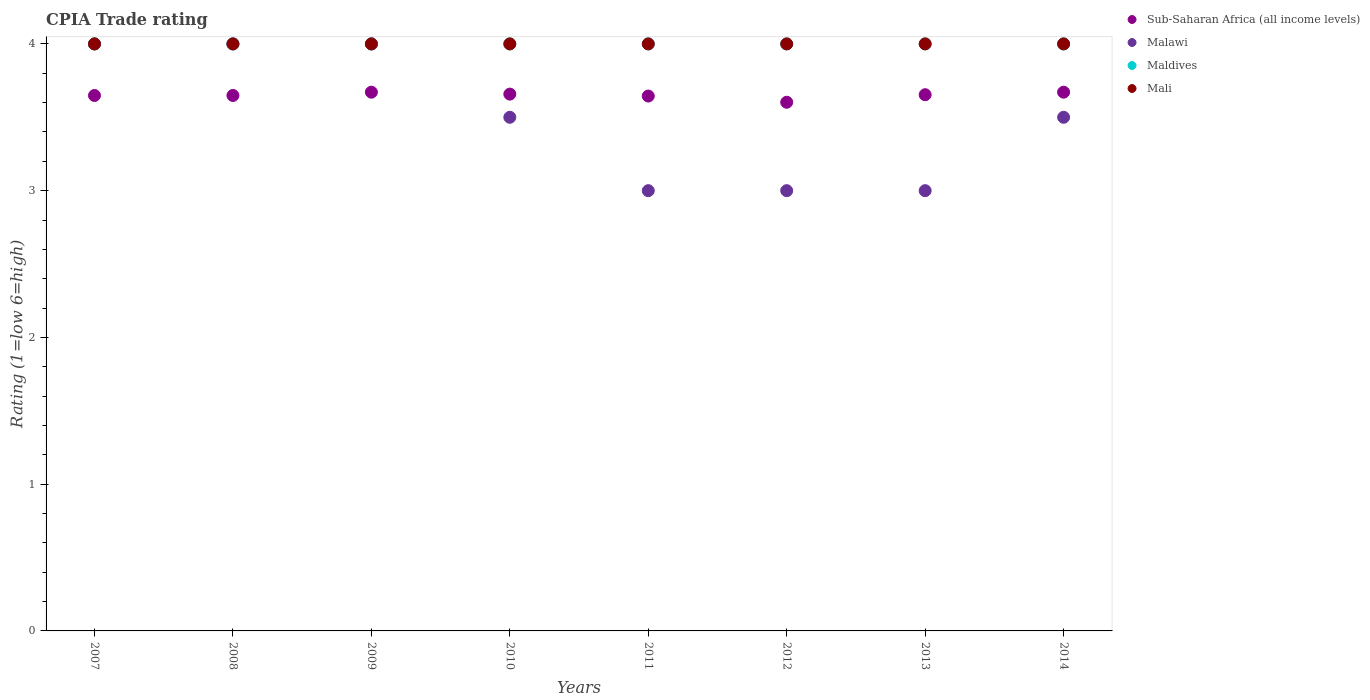What is the CPIA rating in Mali in 2013?
Provide a short and direct response. 4. Across all years, what is the maximum CPIA rating in Sub-Saharan Africa (all income levels)?
Provide a short and direct response. 3.67. Across all years, what is the minimum CPIA rating in Sub-Saharan Africa (all income levels)?
Provide a succinct answer. 3.6. In which year was the CPIA rating in Maldives maximum?
Your response must be concise. 2007. What is the total CPIA rating in Maldives in the graph?
Ensure brevity in your answer.  32. What is the difference between the CPIA rating in Sub-Saharan Africa (all income levels) in 2010 and that in 2011?
Ensure brevity in your answer.  0.01. What is the difference between the CPIA rating in Mali in 2007 and the CPIA rating in Maldives in 2012?
Provide a short and direct response. 0. What is the average CPIA rating in Sub-Saharan Africa (all income levels) per year?
Keep it short and to the point. 3.65. What is the ratio of the CPIA rating in Malawi in 2007 to that in 2012?
Provide a succinct answer. 1.33. Is the CPIA rating in Maldives in 2010 less than that in 2014?
Keep it short and to the point. No. What is the difference between the highest and the second highest CPIA rating in Malawi?
Offer a terse response. 0. What is the difference between the highest and the lowest CPIA rating in Sub-Saharan Africa (all income levels)?
Give a very brief answer. 0.07. Is it the case that in every year, the sum of the CPIA rating in Sub-Saharan Africa (all income levels) and CPIA rating in Mali  is greater than the sum of CPIA rating in Malawi and CPIA rating in Maldives?
Your response must be concise. No. Is it the case that in every year, the sum of the CPIA rating in Sub-Saharan Africa (all income levels) and CPIA rating in Mali  is greater than the CPIA rating in Malawi?
Ensure brevity in your answer.  Yes. How many dotlines are there?
Ensure brevity in your answer.  4. Are the values on the major ticks of Y-axis written in scientific E-notation?
Make the answer very short. No. Where does the legend appear in the graph?
Provide a short and direct response. Top right. How are the legend labels stacked?
Provide a succinct answer. Vertical. What is the title of the graph?
Give a very brief answer. CPIA Trade rating. What is the label or title of the Y-axis?
Offer a terse response. Rating (1=low 6=high). What is the Rating (1=low 6=high) in Sub-Saharan Africa (all income levels) in 2007?
Make the answer very short. 3.65. What is the Rating (1=low 6=high) in Maldives in 2007?
Give a very brief answer. 4. What is the Rating (1=low 6=high) in Mali in 2007?
Keep it short and to the point. 4. What is the Rating (1=low 6=high) of Sub-Saharan Africa (all income levels) in 2008?
Your answer should be compact. 3.65. What is the Rating (1=low 6=high) in Mali in 2008?
Your answer should be compact. 4. What is the Rating (1=low 6=high) of Sub-Saharan Africa (all income levels) in 2009?
Ensure brevity in your answer.  3.67. What is the Rating (1=low 6=high) of Malawi in 2009?
Your answer should be very brief. 4. What is the Rating (1=low 6=high) in Mali in 2009?
Your answer should be very brief. 4. What is the Rating (1=low 6=high) in Sub-Saharan Africa (all income levels) in 2010?
Your answer should be compact. 3.66. What is the Rating (1=low 6=high) in Malawi in 2010?
Provide a short and direct response. 3.5. What is the Rating (1=low 6=high) of Sub-Saharan Africa (all income levels) in 2011?
Make the answer very short. 3.64. What is the Rating (1=low 6=high) of Maldives in 2011?
Your answer should be compact. 4. What is the Rating (1=low 6=high) in Mali in 2011?
Your answer should be very brief. 4. What is the Rating (1=low 6=high) of Sub-Saharan Africa (all income levels) in 2012?
Offer a terse response. 3.6. What is the Rating (1=low 6=high) in Malawi in 2012?
Offer a very short reply. 3. What is the Rating (1=low 6=high) of Maldives in 2012?
Give a very brief answer. 4. What is the Rating (1=low 6=high) in Mali in 2012?
Keep it short and to the point. 4. What is the Rating (1=low 6=high) in Sub-Saharan Africa (all income levels) in 2013?
Provide a short and direct response. 3.65. What is the Rating (1=low 6=high) in Malawi in 2013?
Provide a short and direct response. 3. What is the Rating (1=low 6=high) of Mali in 2013?
Your answer should be very brief. 4. What is the Rating (1=low 6=high) of Sub-Saharan Africa (all income levels) in 2014?
Keep it short and to the point. 3.67. What is the Rating (1=low 6=high) of Maldives in 2014?
Provide a succinct answer. 4. Across all years, what is the maximum Rating (1=low 6=high) in Sub-Saharan Africa (all income levels)?
Your response must be concise. 3.67. Across all years, what is the maximum Rating (1=low 6=high) of Maldives?
Provide a short and direct response. 4. Across all years, what is the maximum Rating (1=low 6=high) of Mali?
Make the answer very short. 4. Across all years, what is the minimum Rating (1=low 6=high) of Sub-Saharan Africa (all income levels)?
Your answer should be compact. 3.6. Across all years, what is the minimum Rating (1=low 6=high) of Maldives?
Offer a very short reply. 4. Across all years, what is the minimum Rating (1=low 6=high) of Mali?
Give a very brief answer. 4. What is the total Rating (1=low 6=high) in Sub-Saharan Africa (all income levels) in the graph?
Ensure brevity in your answer.  29.2. What is the total Rating (1=low 6=high) in Malawi in the graph?
Provide a short and direct response. 28. What is the total Rating (1=low 6=high) of Mali in the graph?
Offer a very short reply. 32. What is the difference between the Rating (1=low 6=high) in Sub-Saharan Africa (all income levels) in 2007 and that in 2008?
Your answer should be compact. 0. What is the difference between the Rating (1=low 6=high) of Maldives in 2007 and that in 2008?
Make the answer very short. 0. What is the difference between the Rating (1=low 6=high) in Mali in 2007 and that in 2008?
Make the answer very short. 0. What is the difference between the Rating (1=low 6=high) in Sub-Saharan Africa (all income levels) in 2007 and that in 2009?
Offer a terse response. -0.02. What is the difference between the Rating (1=low 6=high) in Malawi in 2007 and that in 2009?
Offer a terse response. 0. What is the difference between the Rating (1=low 6=high) in Mali in 2007 and that in 2009?
Offer a very short reply. 0. What is the difference between the Rating (1=low 6=high) of Sub-Saharan Africa (all income levels) in 2007 and that in 2010?
Your response must be concise. -0.01. What is the difference between the Rating (1=low 6=high) in Malawi in 2007 and that in 2010?
Offer a very short reply. 0.5. What is the difference between the Rating (1=low 6=high) in Maldives in 2007 and that in 2010?
Make the answer very short. 0. What is the difference between the Rating (1=low 6=high) of Sub-Saharan Africa (all income levels) in 2007 and that in 2011?
Your answer should be very brief. 0. What is the difference between the Rating (1=low 6=high) of Maldives in 2007 and that in 2011?
Your answer should be very brief. 0. What is the difference between the Rating (1=low 6=high) of Sub-Saharan Africa (all income levels) in 2007 and that in 2012?
Provide a succinct answer. 0.05. What is the difference between the Rating (1=low 6=high) in Mali in 2007 and that in 2012?
Make the answer very short. 0. What is the difference between the Rating (1=low 6=high) in Sub-Saharan Africa (all income levels) in 2007 and that in 2013?
Give a very brief answer. -0.01. What is the difference between the Rating (1=low 6=high) in Malawi in 2007 and that in 2013?
Give a very brief answer. 1. What is the difference between the Rating (1=low 6=high) of Sub-Saharan Africa (all income levels) in 2007 and that in 2014?
Make the answer very short. -0.02. What is the difference between the Rating (1=low 6=high) of Sub-Saharan Africa (all income levels) in 2008 and that in 2009?
Provide a short and direct response. -0.02. What is the difference between the Rating (1=low 6=high) of Mali in 2008 and that in 2009?
Make the answer very short. 0. What is the difference between the Rating (1=low 6=high) in Sub-Saharan Africa (all income levels) in 2008 and that in 2010?
Your response must be concise. -0.01. What is the difference between the Rating (1=low 6=high) in Maldives in 2008 and that in 2010?
Offer a very short reply. 0. What is the difference between the Rating (1=low 6=high) in Sub-Saharan Africa (all income levels) in 2008 and that in 2011?
Make the answer very short. 0. What is the difference between the Rating (1=low 6=high) of Maldives in 2008 and that in 2011?
Ensure brevity in your answer.  0. What is the difference between the Rating (1=low 6=high) in Sub-Saharan Africa (all income levels) in 2008 and that in 2012?
Offer a terse response. 0.05. What is the difference between the Rating (1=low 6=high) in Malawi in 2008 and that in 2012?
Ensure brevity in your answer.  1. What is the difference between the Rating (1=low 6=high) of Sub-Saharan Africa (all income levels) in 2008 and that in 2013?
Your answer should be compact. -0.01. What is the difference between the Rating (1=low 6=high) in Maldives in 2008 and that in 2013?
Provide a succinct answer. 0. What is the difference between the Rating (1=low 6=high) of Sub-Saharan Africa (all income levels) in 2008 and that in 2014?
Your answer should be very brief. -0.02. What is the difference between the Rating (1=low 6=high) of Maldives in 2008 and that in 2014?
Your answer should be very brief. 0. What is the difference between the Rating (1=low 6=high) in Mali in 2008 and that in 2014?
Provide a succinct answer. 0. What is the difference between the Rating (1=low 6=high) of Sub-Saharan Africa (all income levels) in 2009 and that in 2010?
Your response must be concise. 0.01. What is the difference between the Rating (1=low 6=high) in Maldives in 2009 and that in 2010?
Provide a succinct answer. 0. What is the difference between the Rating (1=low 6=high) in Sub-Saharan Africa (all income levels) in 2009 and that in 2011?
Ensure brevity in your answer.  0.03. What is the difference between the Rating (1=low 6=high) in Sub-Saharan Africa (all income levels) in 2009 and that in 2012?
Provide a short and direct response. 0.07. What is the difference between the Rating (1=low 6=high) in Malawi in 2009 and that in 2012?
Make the answer very short. 1. What is the difference between the Rating (1=low 6=high) in Sub-Saharan Africa (all income levels) in 2009 and that in 2013?
Provide a succinct answer. 0.02. What is the difference between the Rating (1=low 6=high) in Malawi in 2009 and that in 2014?
Give a very brief answer. 0.5. What is the difference between the Rating (1=low 6=high) in Maldives in 2009 and that in 2014?
Provide a short and direct response. 0. What is the difference between the Rating (1=low 6=high) in Sub-Saharan Africa (all income levels) in 2010 and that in 2011?
Ensure brevity in your answer.  0.01. What is the difference between the Rating (1=low 6=high) in Malawi in 2010 and that in 2011?
Provide a short and direct response. 0.5. What is the difference between the Rating (1=low 6=high) in Maldives in 2010 and that in 2011?
Ensure brevity in your answer.  0. What is the difference between the Rating (1=low 6=high) of Mali in 2010 and that in 2011?
Provide a short and direct response. 0. What is the difference between the Rating (1=low 6=high) in Sub-Saharan Africa (all income levels) in 2010 and that in 2012?
Offer a terse response. 0.06. What is the difference between the Rating (1=low 6=high) in Sub-Saharan Africa (all income levels) in 2010 and that in 2013?
Your response must be concise. 0. What is the difference between the Rating (1=low 6=high) in Malawi in 2010 and that in 2013?
Ensure brevity in your answer.  0.5. What is the difference between the Rating (1=low 6=high) in Maldives in 2010 and that in 2013?
Ensure brevity in your answer.  0. What is the difference between the Rating (1=low 6=high) in Sub-Saharan Africa (all income levels) in 2010 and that in 2014?
Provide a short and direct response. -0.01. What is the difference between the Rating (1=low 6=high) of Sub-Saharan Africa (all income levels) in 2011 and that in 2012?
Offer a terse response. 0.04. What is the difference between the Rating (1=low 6=high) in Maldives in 2011 and that in 2012?
Your answer should be compact. 0. What is the difference between the Rating (1=low 6=high) in Sub-Saharan Africa (all income levels) in 2011 and that in 2013?
Your response must be concise. -0.01. What is the difference between the Rating (1=low 6=high) in Maldives in 2011 and that in 2013?
Your response must be concise. 0. What is the difference between the Rating (1=low 6=high) of Mali in 2011 and that in 2013?
Offer a very short reply. 0. What is the difference between the Rating (1=low 6=high) of Sub-Saharan Africa (all income levels) in 2011 and that in 2014?
Ensure brevity in your answer.  -0.03. What is the difference between the Rating (1=low 6=high) in Malawi in 2011 and that in 2014?
Provide a succinct answer. -0.5. What is the difference between the Rating (1=low 6=high) in Maldives in 2011 and that in 2014?
Provide a succinct answer. 0. What is the difference between the Rating (1=low 6=high) of Sub-Saharan Africa (all income levels) in 2012 and that in 2013?
Provide a short and direct response. -0.05. What is the difference between the Rating (1=low 6=high) in Maldives in 2012 and that in 2013?
Your response must be concise. 0. What is the difference between the Rating (1=low 6=high) in Mali in 2012 and that in 2013?
Give a very brief answer. 0. What is the difference between the Rating (1=low 6=high) in Sub-Saharan Africa (all income levels) in 2012 and that in 2014?
Your answer should be very brief. -0.07. What is the difference between the Rating (1=low 6=high) of Sub-Saharan Africa (all income levels) in 2013 and that in 2014?
Keep it short and to the point. -0.02. What is the difference between the Rating (1=low 6=high) of Maldives in 2013 and that in 2014?
Offer a very short reply. 0. What is the difference between the Rating (1=low 6=high) in Mali in 2013 and that in 2014?
Your response must be concise. 0. What is the difference between the Rating (1=low 6=high) in Sub-Saharan Africa (all income levels) in 2007 and the Rating (1=low 6=high) in Malawi in 2008?
Your answer should be compact. -0.35. What is the difference between the Rating (1=low 6=high) in Sub-Saharan Africa (all income levels) in 2007 and the Rating (1=low 6=high) in Maldives in 2008?
Give a very brief answer. -0.35. What is the difference between the Rating (1=low 6=high) in Sub-Saharan Africa (all income levels) in 2007 and the Rating (1=low 6=high) in Mali in 2008?
Provide a short and direct response. -0.35. What is the difference between the Rating (1=low 6=high) of Malawi in 2007 and the Rating (1=low 6=high) of Maldives in 2008?
Provide a short and direct response. 0. What is the difference between the Rating (1=low 6=high) in Maldives in 2007 and the Rating (1=low 6=high) in Mali in 2008?
Give a very brief answer. 0. What is the difference between the Rating (1=low 6=high) of Sub-Saharan Africa (all income levels) in 2007 and the Rating (1=low 6=high) of Malawi in 2009?
Ensure brevity in your answer.  -0.35. What is the difference between the Rating (1=low 6=high) in Sub-Saharan Africa (all income levels) in 2007 and the Rating (1=low 6=high) in Maldives in 2009?
Offer a very short reply. -0.35. What is the difference between the Rating (1=low 6=high) in Sub-Saharan Africa (all income levels) in 2007 and the Rating (1=low 6=high) in Mali in 2009?
Provide a short and direct response. -0.35. What is the difference between the Rating (1=low 6=high) in Sub-Saharan Africa (all income levels) in 2007 and the Rating (1=low 6=high) in Malawi in 2010?
Your answer should be very brief. 0.15. What is the difference between the Rating (1=low 6=high) of Sub-Saharan Africa (all income levels) in 2007 and the Rating (1=low 6=high) of Maldives in 2010?
Provide a succinct answer. -0.35. What is the difference between the Rating (1=low 6=high) of Sub-Saharan Africa (all income levels) in 2007 and the Rating (1=low 6=high) of Mali in 2010?
Provide a short and direct response. -0.35. What is the difference between the Rating (1=low 6=high) of Malawi in 2007 and the Rating (1=low 6=high) of Maldives in 2010?
Make the answer very short. 0. What is the difference between the Rating (1=low 6=high) in Malawi in 2007 and the Rating (1=low 6=high) in Mali in 2010?
Your answer should be very brief. 0. What is the difference between the Rating (1=low 6=high) in Sub-Saharan Africa (all income levels) in 2007 and the Rating (1=low 6=high) in Malawi in 2011?
Provide a short and direct response. 0.65. What is the difference between the Rating (1=low 6=high) in Sub-Saharan Africa (all income levels) in 2007 and the Rating (1=low 6=high) in Maldives in 2011?
Make the answer very short. -0.35. What is the difference between the Rating (1=low 6=high) in Sub-Saharan Africa (all income levels) in 2007 and the Rating (1=low 6=high) in Mali in 2011?
Make the answer very short. -0.35. What is the difference between the Rating (1=low 6=high) in Sub-Saharan Africa (all income levels) in 2007 and the Rating (1=low 6=high) in Malawi in 2012?
Offer a very short reply. 0.65. What is the difference between the Rating (1=low 6=high) of Sub-Saharan Africa (all income levels) in 2007 and the Rating (1=low 6=high) of Maldives in 2012?
Your response must be concise. -0.35. What is the difference between the Rating (1=low 6=high) in Sub-Saharan Africa (all income levels) in 2007 and the Rating (1=low 6=high) in Mali in 2012?
Your answer should be compact. -0.35. What is the difference between the Rating (1=low 6=high) of Malawi in 2007 and the Rating (1=low 6=high) of Maldives in 2012?
Your answer should be very brief. 0. What is the difference between the Rating (1=low 6=high) in Sub-Saharan Africa (all income levels) in 2007 and the Rating (1=low 6=high) in Malawi in 2013?
Make the answer very short. 0.65. What is the difference between the Rating (1=low 6=high) of Sub-Saharan Africa (all income levels) in 2007 and the Rating (1=low 6=high) of Maldives in 2013?
Your answer should be very brief. -0.35. What is the difference between the Rating (1=low 6=high) in Sub-Saharan Africa (all income levels) in 2007 and the Rating (1=low 6=high) in Mali in 2013?
Offer a very short reply. -0.35. What is the difference between the Rating (1=low 6=high) in Maldives in 2007 and the Rating (1=low 6=high) in Mali in 2013?
Provide a succinct answer. 0. What is the difference between the Rating (1=low 6=high) of Sub-Saharan Africa (all income levels) in 2007 and the Rating (1=low 6=high) of Malawi in 2014?
Give a very brief answer. 0.15. What is the difference between the Rating (1=low 6=high) of Sub-Saharan Africa (all income levels) in 2007 and the Rating (1=low 6=high) of Maldives in 2014?
Keep it short and to the point. -0.35. What is the difference between the Rating (1=low 6=high) of Sub-Saharan Africa (all income levels) in 2007 and the Rating (1=low 6=high) of Mali in 2014?
Your answer should be very brief. -0.35. What is the difference between the Rating (1=low 6=high) in Malawi in 2007 and the Rating (1=low 6=high) in Maldives in 2014?
Your answer should be very brief. 0. What is the difference between the Rating (1=low 6=high) of Malawi in 2007 and the Rating (1=low 6=high) of Mali in 2014?
Give a very brief answer. 0. What is the difference between the Rating (1=low 6=high) of Sub-Saharan Africa (all income levels) in 2008 and the Rating (1=low 6=high) of Malawi in 2009?
Give a very brief answer. -0.35. What is the difference between the Rating (1=low 6=high) of Sub-Saharan Africa (all income levels) in 2008 and the Rating (1=low 6=high) of Maldives in 2009?
Offer a terse response. -0.35. What is the difference between the Rating (1=low 6=high) in Sub-Saharan Africa (all income levels) in 2008 and the Rating (1=low 6=high) in Mali in 2009?
Provide a succinct answer. -0.35. What is the difference between the Rating (1=low 6=high) of Maldives in 2008 and the Rating (1=low 6=high) of Mali in 2009?
Make the answer very short. 0. What is the difference between the Rating (1=low 6=high) in Sub-Saharan Africa (all income levels) in 2008 and the Rating (1=low 6=high) in Malawi in 2010?
Provide a succinct answer. 0.15. What is the difference between the Rating (1=low 6=high) in Sub-Saharan Africa (all income levels) in 2008 and the Rating (1=low 6=high) in Maldives in 2010?
Offer a terse response. -0.35. What is the difference between the Rating (1=low 6=high) in Sub-Saharan Africa (all income levels) in 2008 and the Rating (1=low 6=high) in Mali in 2010?
Offer a terse response. -0.35. What is the difference between the Rating (1=low 6=high) of Malawi in 2008 and the Rating (1=low 6=high) of Maldives in 2010?
Make the answer very short. 0. What is the difference between the Rating (1=low 6=high) in Maldives in 2008 and the Rating (1=low 6=high) in Mali in 2010?
Ensure brevity in your answer.  0. What is the difference between the Rating (1=low 6=high) of Sub-Saharan Africa (all income levels) in 2008 and the Rating (1=low 6=high) of Malawi in 2011?
Your answer should be compact. 0.65. What is the difference between the Rating (1=low 6=high) in Sub-Saharan Africa (all income levels) in 2008 and the Rating (1=low 6=high) in Maldives in 2011?
Make the answer very short. -0.35. What is the difference between the Rating (1=low 6=high) of Sub-Saharan Africa (all income levels) in 2008 and the Rating (1=low 6=high) of Mali in 2011?
Your response must be concise. -0.35. What is the difference between the Rating (1=low 6=high) of Sub-Saharan Africa (all income levels) in 2008 and the Rating (1=low 6=high) of Malawi in 2012?
Keep it short and to the point. 0.65. What is the difference between the Rating (1=low 6=high) of Sub-Saharan Africa (all income levels) in 2008 and the Rating (1=low 6=high) of Maldives in 2012?
Ensure brevity in your answer.  -0.35. What is the difference between the Rating (1=low 6=high) of Sub-Saharan Africa (all income levels) in 2008 and the Rating (1=low 6=high) of Mali in 2012?
Offer a very short reply. -0.35. What is the difference between the Rating (1=low 6=high) of Malawi in 2008 and the Rating (1=low 6=high) of Maldives in 2012?
Keep it short and to the point. 0. What is the difference between the Rating (1=low 6=high) in Malawi in 2008 and the Rating (1=low 6=high) in Mali in 2012?
Offer a terse response. 0. What is the difference between the Rating (1=low 6=high) of Sub-Saharan Africa (all income levels) in 2008 and the Rating (1=low 6=high) of Malawi in 2013?
Provide a short and direct response. 0.65. What is the difference between the Rating (1=low 6=high) of Sub-Saharan Africa (all income levels) in 2008 and the Rating (1=low 6=high) of Maldives in 2013?
Your answer should be very brief. -0.35. What is the difference between the Rating (1=low 6=high) in Sub-Saharan Africa (all income levels) in 2008 and the Rating (1=low 6=high) in Mali in 2013?
Provide a succinct answer. -0.35. What is the difference between the Rating (1=low 6=high) of Malawi in 2008 and the Rating (1=low 6=high) of Mali in 2013?
Offer a very short reply. 0. What is the difference between the Rating (1=low 6=high) of Maldives in 2008 and the Rating (1=low 6=high) of Mali in 2013?
Offer a very short reply. 0. What is the difference between the Rating (1=low 6=high) in Sub-Saharan Africa (all income levels) in 2008 and the Rating (1=low 6=high) in Malawi in 2014?
Offer a terse response. 0.15. What is the difference between the Rating (1=low 6=high) in Sub-Saharan Africa (all income levels) in 2008 and the Rating (1=low 6=high) in Maldives in 2014?
Give a very brief answer. -0.35. What is the difference between the Rating (1=low 6=high) in Sub-Saharan Africa (all income levels) in 2008 and the Rating (1=low 6=high) in Mali in 2014?
Your answer should be very brief. -0.35. What is the difference between the Rating (1=low 6=high) of Malawi in 2008 and the Rating (1=low 6=high) of Maldives in 2014?
Offer a terse response. 0. What is the difference between the Rating (1=low 6=high) in Malawi in 2008 and the Rating (1=low 6=high) in Mali in 2014?
Ensure brevity in your answer.  0. What is the difference between the Rating (1=low 6=high) of Maldives in 2008 and the Rating (1=low 6=high) of Mali in 2014?
Ensure brevity in your answer.  0. What is the difference between the Rating (1=low 6=high) of Sub-Saharan Africa (all income levels) in 2009 and the Rating (1=low 6=high) of Malawi in 2010?
Offer a very short reply. 0.17. What is the difference between the Rating (1=low 6=high) of Sub-Saharan Africa (all income levels) in 2009 and the Rating (1=low 6=high) of Maldives in 2010?
Provide a succinct answer. -0.33. What is the difference between the Rating (1=low 6=high) of Sub-Saharan Africa (all income levels) in 2009 and the Rating (1=low 6=high) of Mali in 2010?
Make the answer very short. -0.33. What is the difference between the Rating (1=low 6=high) of Malawi in 2009 and the Rating (1=low 6=high) of Maldives in 2010?
Offer a terse response. 0. What is the difference between the Rating (1=low 6=high) of Malawi in 2009 and the Rating (1=low 6=high) of Mali in 2010?
Provide a succinct answer. 0. What is the difference between the Rating (1=low 6=high) of Maldives in 2009 and the Rating (1=low 6=high) of Mali in 2010?
Provide a short and direct response. 0. What is the difference between the Rating (1=low 6=high) in Sub-Saharan Africa (all income levels) in 2009 and the Rating (1=low 6=high) in Malawi in 2011?
Your response must be concise. 0.67. What is the difference between the Rating (1=low 6=high) in Sub-Saharan Africa (all income levels) in 2009 and the Rating (1=low 6=high) in Maldives in 2011?
Give a very brief answer. -0.33. What is the difference between the Rating (1=low 6=high) in Sub-Saharan Africa (all income levels) in 2009 and the Rating (1=low 6=high) in Mali in 2011?
Give a very brief answer. -0.33. What is the difference between the Rating (1=low 6=high) of Malawi in 2009 and the Rating (1=low 6=high) of Mali in 2011?
Offer a terse response. 0. What is the difference between the Rating (1=low 6=high) in Sub-Saharan Africa (all income levels) in 2009 and the Rating (1=low 6=high) in Malawi in 2012?
Make the answer very short. 0.67. What is the difference between the Rating (1=low 6=high) of Sub-Saharan Africa (all income levels) in 2009 and the Rating (1=low 6=high) of Maldives in 2012?
Make the answer very short. -0.33. What is the difference between the Rating (1=low 6=high) of Sub-Saharan Africa (all income levels) in 2009 and the Rating (1=low 6=high) of Mali in 2012?
Provide a short and direct response. -0.33. What is the difference between the Rating (1=low 6=high) in Malawi in 2009 and the Rating (1=low 6=high) in Maldives in 2012?
Offer a very short reply. 0. What is the difference between the Rating (1=low 6=high) in Malawi in 2009 and the Rating (1=low 6=high) in Mali in 2012?
Your answer should be very brief. 0. What is the difference between the Rating (1=low 6=high) in Maldives in 2009 and the Rating (1=low 6=high) in Mali in 2012?
Give a very brief answer. 0. What is the difference between the Rating (1=low 6=high) in Sub-Saharan Africa (all income levels) in 2009 and the Rating (1=low 6=high) in Malawi in 2013?
Offer a terse response. 0.67. What is the difference between the Rating (1=low 6=high) of Sub-Saharan Africa (all income levels) in 2009 and the Rating (1=low 6=high) of Maldives in 2013?
Offer a terse response. -0.33. What is the difference between the Rating (1=low 6=high) of Sub-Saharan Africa (all income levels) in 2009 and the Rating (1=low 6=high) of Mali in 2013?
Make the answer very short. -0.33. What is the difference between the Rating (1=low 6=high) in Malawi in 2009 and the Rating (1=low 6=high) in Maldives in 2013?
Offer a very short reply. 0. What is the difference between the Rating (1=low 6=high) in Malawi in 2009 and the Rating (1=low 6=high) in Mali in 2013?
Your response must be concise. 0. What is the difference between the Rating (1=low 6=high) in Maldives in 2009 and the Rating (1=low 6=high) in Mali in 2013?
Give a very brief answer. 0. What is the difference between the Rating (1=low 6=high) in Sub-Saharan Africa (all income levels) in 2009 and the Rating (1=low 6=high) in Malawi in 2014?
Your response must be concise. 0.17. What is the difference between the Rating (1=low 6=high) of Sub-Saharan Africa (all income levels) in 2009 and the Rating (1=low 6=high) of Maldives in 2014?
Offer a terse response. -0.33. What is the difference between the Rating (1=low 6=high) in Sub-Saharan Africa (all income levels) in 2009 and the Rating (1=low 6=high) in Mali in 2014?
Your answer should be compact. -0.33. What is the difference between the Rating (1=low 6=high) of Malawi in 2009 and the Rating (1=low 6=high) of Maldives in 2014?
Offer a very short reply. 0. What is the difference between the Rating (1=low 6=high) of Malawi in 2009 and the Rating (1=low 6=high) of Mali in 2014?
Give a very brief answer. 0. What is the difference between the Rating (1=low 6=high) in Maldives in 2009 and the Rating (1=low 6=high) in Mali in 2014?
Your response must be concise. 0. What is the difference between the Rating (1=low 6=high) of Sub-Saharan Africa (all income levels) in 2010 and the Rating (1=low 6=high) of Malawi in 2011?
Give a very brief answer. 0.66. What is the difference between the Rating (1=low 6=high) of Sub-Saharan Africa (all income levels) in 2010 and the Rating (1=low 6=high) of Maldives in 2011?
Ensure brevity in your answer.  -0.34. What is the difference between the Rating (1=low 6=high) in Sub-Saharan Africa (all income levels) in 2010 and the Rating (1=low 6=high) in Mali in 2011?
Your response must be concise. -0.34. What is the difference between the Rating (1=low 6=high) in Malawi in 2010 and the Rating (1=low 6=high) in Maldives in 2011?
Your response must be concise. -0.5. What is the difference between the Rating (1=low 6=high) in Sub-Saharan Africa (all income levels) in 2010 and the Rating (1=low 6=high) in Malawi in 2012?
Make the answer very short. 0.66. What is the difference between the Rating (1=low 6=high) in Sub-Saharan Africa (all income levels) in 2010 and the Rating (1=low 6=high) in Maldives in 2012?
Your answer should be compact. -0.34. What is the difference between the Rating (1=low 6=high) in Sub-Saharan Africa (all income levels) in 2010 and the Rating (1=low 6=high) in Mali in 2012?
Make the answer very short. -0.34. What is the difference between the Rating (1=low 6=high) of Malawi in 2010 and the Rating (1=low 6=high) of Maldives in 2012?
Your answer should be very brief. -0.5. What is the difference between the Rating (1=low 6=high) in Sub-Saharan Africa (all income levels) in 2010 and the Rating (1=low 6=high) in Malawi in 2013?
Provide a succinct answer. 0.66. What is the difference between the Rating (1=low 6=high) of Sub-Saharan Africa (all income levels) in 2010 and the Rating (1=low 6=high) of Maldives in 2013?
Make the answer very short. -0.34. What is the difference between the Rating (1=low 6=high) of Sub-Saharan Africa (all income levels) in 2010 and the Rating (1=low 6=high) of Mali in 2013?
Your answer should be very brief. -0.34. What is the difference between the Rating (1=low 6=high) in Sub-Saharan Africa (all income levels) in 2010 and the Rating (1=low 6=high) in Malawi in 2014?
Provide a succinct answer. 0.16. What is the difference between the Rating (1=low 6=high) in Sub-Saharan Africa (all income levels) in 2010 and the Rating (1=low 6=high) in Maldives in 2014?
Give a very brief answer. -0.34. What is the difference between the Rating (1=low 6=high) in Sub-Saharan Africa (all income levels) in 2010 and the Rating (1=low 6=high) in Mali in 2014?
Give a very brief answer. -0.34. What is the difference between the Rating (1=low 6=high) in Malawi in 2010 and the Rating (1=low 6=high) in Mali in 2014?
Make the answer very short. -0.5. What is the difference between the Rating (1=low 6=high) of Maldives in 2010 and the Rating (1=low 6=high) of Mali in 2014?
Ensure brevity in your answer.  0. What is the difference between the Rating (1=low 6=high) of Sub-Saharan Africa (all income levels) in 2011 and the Rating (1=low 6=high) of Malawi in 2012?
Keep it short and to the point. 0.64. What is the difference between the Rating (1=low 6=high) in Sub-Saharan Africa (all income levels) in 2011 and the Rating (1=low 6=high) in Maldives in 2012?
Make the answer very short. -0.36. What is the difference between the Rating (1=low 6=high) of Sub-Saharan Africa (all income levels) in 2011 and the Rating (1=low 6=high) of Mali in 2012?
Keep it short and to the point. -0.36. What is the difference between the Rating (1=low 6=high) in Malawi in 2011 and the Rating (1=low 6=high) in Maldives in 2012?
Offer a very short reply. -1. What is the difference between the Rating (1=low 6=high) of Malawi in 2011 and the Rating (1=low 6=high) of Mali in 2012?
Offer a very short reply. -1. What is the difference between the Rating (1=low 6=high) in Sub-Saharan Africa (all income levels) in 2011 and the Rating (1=low 6=high) in Malawi in 2013?
Ensure brevity in your answer.  0.64. What is the difference between the Rating (1=low 6=high) in Sub-Saharan Africa (all income levels) in 2011 and the Rating (1=low 6=high) in Maldives in 2013?
Provide a short and direct response. -0.36. What is the difference between the Rating (1=low 6=high) of Sub-Saharan Africa (all income levels) in 2011 and the Rating (1=low 6=high) of Mali in 2013?
Offer a terse response. -0.36. What is the difference between the Rating (1=low 6=high) in Sub-Saharan Africa (all income levels) in 2011 and the Rating (1=low 6=high) in Malawi in 2014?
Ensure brevity in your answer.  0.14. What is the difference between the Rating (1=low 6=high) in Sub-Saharan Africa (all income levels) in 2011 and the Rating (1=low 6=high) in Maldives in 2014?
Offer a very short reply. -0.36. What is the difference between the Rating (1=low 6=high) in Sub-Saharan Africa (all income levels) in 2011 and the Rating (1=low 6=high) in Mali in 2014?
Give a very brief answer. -0.36. What is the difference between the Rating (1=low 6=high) of Malawi in 2011 and the Rating (1=low 6=high) of Maldives in 2014?
Provide a short and direct response. -1. What is the difference between the Rating (1=low 6=high) in Malawi in 2011 and the Rating (1=low 6=high) in Mali in 2014?
Your answer should be compact. -1. What is the difference between the Rating (1=low 6=high) of Sub-Saharan Africa (all income levels) in 2012 and the Rating (1=low 6=high) of Malawi in 2013?
Make the answer very short. 0.6. What is the difference between the Rating (1=low 6=high) of Sub-Saharan Africa (all income levels) in 2012 and the Rating (1=low 6=high) of Maldives in 2013?
Keep it short and to the point. -0.4. What is the difference between the Rating (1=low 6=high) in Sub-Saharan Africa (all income levels) in 2012 and the Rating (1=low 6=high) in Mali in 2013?
Offer a very short reply. -0.4. What is the difference between the Rating (1=low 6=high) of Malawi in 2012 and the Rating (1=low 6=high) of Maldives in 2013?
Offer a very short reply. -1. What is the difference between the Rating (1=low 6=high) in Sub-Saharan Africa (all income levels) in 2012 and the Rating (1=low 6=high) in Malawi in 2014?
Your answer should be very brief. 0.1. What is the difference between the Rating (1=low 6=high) in Sub-Saharan Africa (all income levels) in 2012 and the Rating (1=low 6=high) in Maldives in 2014?
Ensure brevity in your answer.  -0.4. What is the difference between the Rating (1=low 6=high) in Sub-Saharan Africa (all income levels) in 2012 and the Rating (1=low 6=high) in Mali in 2014?
Offer a terse response. -0.4. What is the difference between the Rating (1=low 6=high) of Malawi in 2012 and the Rating (1=low 6=high) of Mali in 2014?
Your answer should be compact. -1. What is the difference between the Rating (1=low 6=high) of Sub-Saharan Africa (all income levels) in 2013 and the Rating (1=low 6=high) of Malawi in 2014?
Keep it short and to the point. 0.15. What is the difference between the Rating (1=low 6=high) of Sub-Saharan Africa (all income levels) in 2013 and the Rating (1=low 6=high) of Maldives in 2014?
Keep it short and to the point. -0.35. What is the difference between the Rating (1=low 6=high) of Sub-Saharan Africa (all income levels) in 2013 and the Rating (1=low 6=high) of Mali in 2014?
Provide a short and direct response. -0.35. What is the difference between the Rating (1=low 6=high) in Malawi in 2013 and the Rating (1=low 6=high) in Maldives in 2014?
Give a very brief answer. -1. What is the difference between the Rating (1=low 6=high) in Maldives in 2013 and the Rating (1=low 6=high) in Mali in 2014?
Offer a terse response. 0. What is the average Rating (1=low 6=high) of Sub-Saharan Africa (all income levels) per year?
Your answer should be very brief. 3.65. What is the average Rating (1=low 6=high) in Mali per year?
Provide a succinct answer. 4. In the year 2007, what is the difference between the Rating (1=low 6=high) of Sub-Saharan Africa (all income levels) and Rating (1=low 6=high) of Malawi?
Offer a terse response. -0.35. In the year 2007, what is the difference between the Rating (1=low 6=high) in Sub-Saharan Africa (all income levels) and Rating (1=low 6=high) in Maldives?
Keep it short and to the point. -0.35. In the year 2007, what is the difference between the Rating (1=low 6=high) of Sub-Saharan Africa (all income levels) and Rating (1=low 6=high) of Mali?
Offer a terse response. -0.35. In the year 2007, what is the difference between the Rating (1=low 6=high) of Maldives and Rating (1=low 6=high) of Mali?
Ensure brevity in your answer.  0. In the year 2008, what is the difference between the Rating (1=low 6=high) of Sub-Saharan Africa (all income levels) and Rating (1=low 6=high) of Malawi?
Your response must be concise. -0.35. In the year 2008, what is the difference between the Rating (1=low 6=high) of Sub-Saharan Africa (all income levels) and Rating (1=low 6=high) of Maldives?
Give a very brief answer. -0.35. In the year 2008, what is the difference between the Rating (1=low 6=high) in Sub-Saharan Africa (all income levels) and Rating (1=low 6=high) in Mali?
Provide a succinct answer. -0.35. In the year 2009, what is the difference between the Rating (1=low 6=high) of Sub-Saharan Africa (all income levels) and Rating (1=low 6=high) of Malawi?
Provide a short and direct response. -0.33. In the year 2009, what is the difference between the Rating (1=low 6=high) of Sub-Saharan Africa (all income levels) and Rating (1=low 6=high) of Maldives?
Make the answer very short. -0.33. In the year 2009, what is the difference between the Rating (1=low 6=high) in Sub-Saharan Africa (all income levels) and Rating (1=low 6=high) in Mali?
Your answer should be compact. -0.33. In the year 2009, what is the difference between the Rating (1=low 6=high) of Malawi and Rating (1=low 6=high) of Mali?
Offer a very short reply. 0. In the year 2009, what is the difference between the Rating (1=low 6=high) of Maldives and Rating (1=low 6=high) of Mali?
Offer a terse response. 0. In the year 2010, what is the difference between the Rating (1=low 6=high) of Sub-Saharan Africa (all income levels) and Rating (1=low 6=high) of Malawi?
Offer a terse response. 0.16. In the year 2010, what is the difference between the Rating (1=low 6=high) of Sub-Saharan Africa (all income levels) and Rating (1=low 6=high) of Maldives?
Make the answer very short. -0.34. In the year 2010, what is the difference between the Rating (1=low 6=high) of Sub-Saharan Africa (all income levels) and Rating (1=low 6=high) of Mali?
Make the answer very short. -0.34. In the year 2010, what is the difference between the Rating (1=low 6=high) in Malawi and Rating (1=low 6=high) in Mali?
Give a very brief answer. -0.5. In the year 2011, what is the difference between the Rating (1=low 6=high) of Sub-Saharan Africa (all income levels) and Rating (1=low 6=high) of Malawi?
Make the answer very short. 0.64. In the year 2011, what is the difference between the Rating (1=low 6=high) in Sub-Saharan Africa (all income levels) and Rating (1=low 6=high) in Maldives?
Provide a succinct answer. -0.36. In the year 2011, what is the difference between the Rating (1=low 6=high) in Sub-Saharan Africa (all income levels) and Rating (1=low 6=high) in Mali?
Make the answer very short. -0.36. In the year 2011, what is the difference between the Rating (1=low 6=high) of Malawi and Rating (1=low 6=high) of Maldives?
Your response must be concise. -1. In the year 2012, what is the difference between the Rating (1=low 6=high) in Sub-Saharan Africa (all income levels) and Rating (1=low 6=high) in Malawi?
Your answer should be compact. 0.6. In the year 2012, what is the difference between the Rating (1=low 6=high) in Sub-Saharan Africa (all income levels) and Rating (1=low 6=high) in Maldives?
Provide a short and direct response. -0.4. In the year 2012, what is the difference between the Rating (1=low 6=high) in Sub-Saharan Africa (all income levels) and Rating (1=low 6=high) in Mali?
Ensure brevity in your answer.  -0.4. In the year 2012, what is the difference between the Rating (1=low 6=high) of Maldives and Rating (1=low 6=high) of Mali?
Your response must be concise. 0. In the year 2013, what is the difference between the Rating (1=low 6=high) of Sub-Saharan Africa (all income levels) and Rating (1=low 6=high) of Malawi?
Make the answer very short. 0.65. In the year 2013, what is the difference between the Rating (1=low 6=high) in Sub-Saharan Africa (all income levels) and Rating (1=low 6=high) in Maldives?
Ensure brevity in your answer.  -0.35. In the year 2013, what is the difference between the Rating (1=low 6=high) in Sub-Saharan Africa (all income levels) and Rating (1=low 6=high) in Mali?
Your response must be concise. -0.35. In the year 2013, what is the difference between the Rating (1=low 6=high) of Malawi and Rating (1=low 6=high) of Mali?
Give a very brief answer. -1. In the year 2013, what is the difference between the Rating (1=low 6=high) of Maldives and Rating (1=low 6=high) of Mali?
Give a very brief answer. 0. In the year 2014, what is the difference between the Rating (1=low 6=high) of Sub-Saharan Africa (all income levels) and Rating (1=low 6=high) of Malawi?
Your response must be concise. 0.17. In the year 2014, what is the difference between the Rating (1=low 6=high) in Sub-Saharan Africa (all income levels) and Rating (1=low 6=high) in Maldives?
Provide a short and direct response. -0.33. In the year 2014, what is the difference between the Rating (1=low 6=high) of Sub-Saharan Africa (all income levels) and Rating (1=low 6=high) of Mali?
Provide a succinct answer. -0.33. In the year 2014, what is the difference between the Rating (1=low 6=high) in Maldives and Rating (1=low 6=high) in Mali?
Offer a very short reply. 0. What is the ratio of the Rating (1=low 6=high) in Malawi in 2007 to that in 2008?
Keep it short and to the point. 1. What is the ratio of the Rating (1=low 6=high) in Maldives in 2007 to that in 2008?
Ensure brevity in your answer.  1. What is the ratio of the Rating (1=low 6=high) in Mali in 2007 to that in 2009?
Make the answer very short. 1. What is the ratio of the Rating (1=low 6=high) in Sub-Saharan Africa (all income levels) in 2007 to that in 2010?
Your answer should be compact. 1. What is the ratio of the Rating (1=low 6=high) in Maldives in 2007 to that in 2010?
Your response must be concise. 1. What is the ratio of the Rating (1=low 6=high) of Mali in 2007 to that in 2010?
Offer a terse response. 1. What is the ratio of the Rating (1=low 6=high) in Sub-Saharan Africa (all income levels) in 2007 to that in 2011?
Make the answer very short. 1. What is the ratio of the Rating (1=low 6=high) in Sub-Saharan Africa (all income levels) in 2007 to that in 2012?
Provide a short and direct response. 1.01. What is the ratio of the Rating (1=low 6=high) of Malawi in 2007 to that in 2013?
Keep it short and to the point. 1.33. What is the ratio of the Rating (1=low 6=high) in Mali in 2007 to that in 2013?
Your answer should be very brief. 1. What is the ratio of the Rating (1=low 6=high) in Maldives in 2007 to that in 2014?
Ensure brevity in your answer.  1. What is the ratio of the Rating (1=low 6=high) of Malawi in 2008 to that in 2009?
Provide a short and direct response. 1. What is the ratio of the Rating (1=low 6=high) of Maldives in 2008 to that in 2009?
Your answer should be very brief. 1. What is the ratio of the Rating (1=low 6=high) in Mali in 2008 to that in 2009?
Offer a terse response. 1. What is the ratio of the Rating (1=low 6=high) of Malawi in 2008 to that in 2011?
Ensure brevity in your answer.  1.33. What is the ratio of the Rating (1=low 6=high) of Maldives in 2008 to that in 2011?
Give a very brief answer. 1. What is the ratio of the Rating (1=low 6=high) in Sub-Saharan Africa (all income levels) in 2008 to that in 2012?
Your answer should be compact. 1.01. What is the ratio of the Rating (1=low 6=high) in Malawi in 2008 to that in 2012?
Offer a very short reply. 1.33. What is the ratio of the Rating (1=low 6=high) of Maldives in 2008 to that in 2012?
Keep it short and to the point. 1. What is the ratio of the Rating (1=low 6=high) in Mali in 2008 to that in 2012?
Your answer should be compact. 1. What is the ratio of the Rating (1=low 6=high) in Sub-Saharan Africa (all income levels) in 2008 to that in 2013?
Keep it short and to the point. 1. What is the ratio of the Rating (1=low 6=high) of Mali in 2008 to that in 2013?
Keep it short and to the point. 1. What is the ratio of the Rating (1=low 6=high) in Malawi in 2008 to that in 2014?
Provide a short and direct response. 1.14. What is the ratio of the Rating (1=low 6=high) of Malawi in 2009 to that in 2010?
Make the answer very short. 1.14. What is the ratio of the Rating (1=low 6=high) of Maldives in 2009 to that in 2010?
Your answer should be very brief. 1. What is the ratio of the Rating (1=low 6=high) in Mali in 2009 to that in 2010?
Provide a succinct answer. 1. What is the ratio of the Rating (1=low 6=high) in Malawi in 2009 to that in 2011?
Offer a terse response. 1.33. What is the ratio of the Rating (1=low 6=high) of Mali in 2009 to that in 2011?
Offer a very short reply. 1. What is the ratio of the Rating (1=low 6=high) of Malawi in 2009 to that in 2012?
Give a very brief answer. 1.33. What is the ratio of the Rating (1=low 6=high) of Mali in 2009 to that in 2012?
Your response must be concise. 1. What is the ratio of the Rating (1=low 6=high) in Sub-Saharan Africa (all income levels) in 2009 to that in 2013?
Your answer should be compact. 1. What is the ratio of the Rating (1=low 6=high) in Mali in 2009 to that in 2013?
Make the answer very short. 1. What is the ratio of the Rating (1=low 6=high) of Mali in 2009 to that in 2014?
Offer a terse response. 1. What is the ratio of the Rating (1=low 6=high) of Sub-Saharan Africa (all income levels) in 2010 to that in 2011?
Offer a very short reply. 1. What is the ratio of the Rating (1=low 6=high) of Malawi in 2010 to that in 2011?
Give a very brief answer. 1.17. What is the ratio of the Rating (1=low 6=high) of Sub-Saharan Africa (all income levels) in 2010 to that in 2012?
Offer a very short reply. 1.02. What is the ratio of the Rating (1=low 6=high) of Maldives in 2010 to that in 2012?
Provide a short and direct response. 1. What is the ratio of the Rating (1=low 6=high) in Mali in 2010 to that in 2012?
Provide a short and direct response. 1. What is the ratio of the Rating (1=low 6=high) of Malawi in 2010 to that in 2013?
Offer a very short reply. 1.17. What is the ratio of the Rating (1=low 6=high) in Mali in 2010 to that in 2013?
Make the answer very short. 1. What is the ratio of the Rating (1=low 6=high) of Sub-Saharan Africa (all income levels) in 2011 to that in 2012?
Provide a short and direct response. 1.01. What is the ratio of the Rating (1=low 6=high) of Malawi in 2011 to that in 2012?
Your answer should be very brief. 1. What is the ratio of the Rating (1=low 6=high) of Maldives in 2011 to that in 2012?
Make the answer very short. 1. What is the ratio of the Rating (1=low 6=high) of Mali in 2011 to that in 2012?
Provide a succinct answer. 1. What is the ratio of the Rating (1=low 6=high) of Maldives in 2011 to that in 2013?
Ensure brevity in your answer.  1. What is the ratio of the Rating (1=low 6=high) in Sub-Saharan Africa (all income levels) in 2011 to that in 2014?
Make the answer very short. 0.99. What is the ratio of the Rating (1=low 6=high) of Malawi in 2011 to that in 2014?
Ensure brevity in your answer.  0.86. What is the ratio of the Rating (1=low 6=high) in Maldives in 2011 to that in 2014?
Make the answer very short. 1. What is the ratio of the Rating (1=low 6=high) of Mali in 2011 to that in 2014?
Ensure brevity in your answer.  1. What is the ratio of the Rating (1=low 6=high) in Sub-Saharan Africa (all income levels) in 2012 to that in 2013?
Offer a very short reply. 0.99. What is the ratio of the Rating (1=low 6=high) of Mali in 2012 to that in 2013?
Your answer should be very brief. 1. What is the ratio of the Rating (1=low 6=high) in Sub-Saharan Africa (all income levels) in 2012 to that in 2014?
Offer a terse response. 0.98. What is the ratio of the Rating (1=low 6=high) of Mali in 2012 to that in 2014?
Keep it short and to the point. 1. What is the ratio of the Rating (1=low 6=high) in Mali in 2013 to that in 2014?
Offer a very short reply. 1. What is the difference between the highest and the second highest Rating (1=low 6=high) of Maldives?
Provide a succinct answer. 0. What is the difference between the highest and the second highest Rating (1=low 6=high) of Mali?
Give a very brief answer. 0. What is the difference between the highest and the lowest Rating (1=low 6=high) of Sub-Saharan Africa (all income levels)?
Your response must be concise. 0.07. What is the difference between the highest and the lowest Rating (1=low 6=high) in Malawi?
Give a very brief answer. 1. What is the difference between the highest and the lowest Rating (1=low 6=high) of Maldives?
Ensure brevity in your answer.  0. 